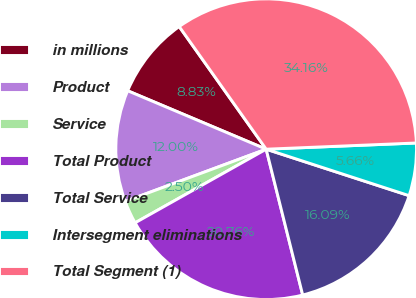<chart> <loc_0><loc_0><loc_500><loc_500><pie_chart><fcel>in millions<fcel>Product<fcel>Service<fcel>Total Product<fcel>Total Service<fcel>Intersegment eliminations<fcel>Total Segment (1)<nl><fcel>8.83%<fcel>12.0%<fcel>2.5%<fcel>20.76%<fcel>16.09%<fcel>5.66%<fcel>34.16%<nl></chart> 